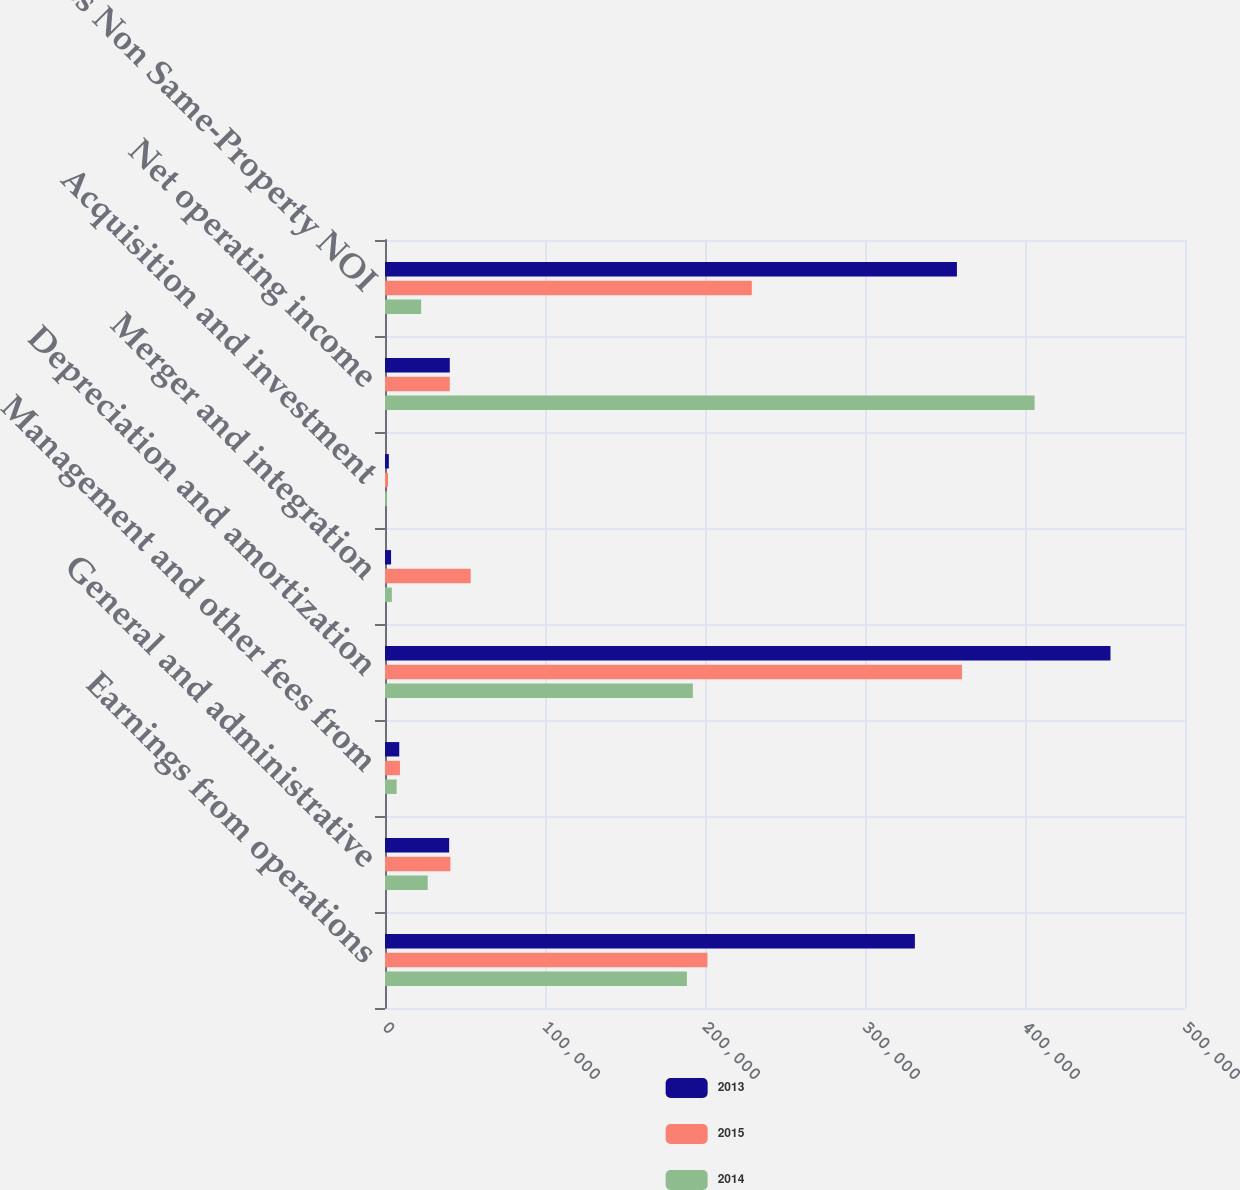Convert chart. <chart><loc_0><loc_0><loc_500><loc_500><stacked_bar_chart><ecel><fcel>Earnings from operations<fcel>General and administrative<fcel>Management and other fees from<fcel>Depreciation and amortization<fcel>Merger and integration<fcel>Acquisition and investment<fcel>Net operating income<fcel>Less Non Same-Property NOI<nl><fcel>2013<fcel>331174<fcel>40090<fcel>8909<fcel>453423<fcel>3798<fcel>2414<fcel>40484<fcel>357457<nl><fcel>2015<fcel>201514<fcel>40878<fcel>9347<fcel>360592<fcel>53530<fcel>1878<fcel>40484<fcel>229244<nl><fcel>2014<fcel>188705<fcel>26684<fcel>7263<fcel>192420<fcel>4284<fcel>1161<fcel>405991<fcel>22599<nl></chart> 